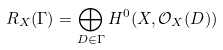Convert formula to latex. <formula><loc_0><loc_0><loc_500><loc_500>R _ { X } ( \Gamma ) = \bigoplus _ { D \in \Gamma } H ^ { 0 } ( X , \mathcal { O } _ { X } ( D ) )</formula> 